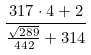Convert formula to latex. <formula><loc_0><loc_0><loc_500><loc_500>\frac { 3 1 7 \cdot 4 + 2 } { \frac { \sqrt { 2 8 9 } } { 4 4 2 } + 3 1 4 }</formula> 